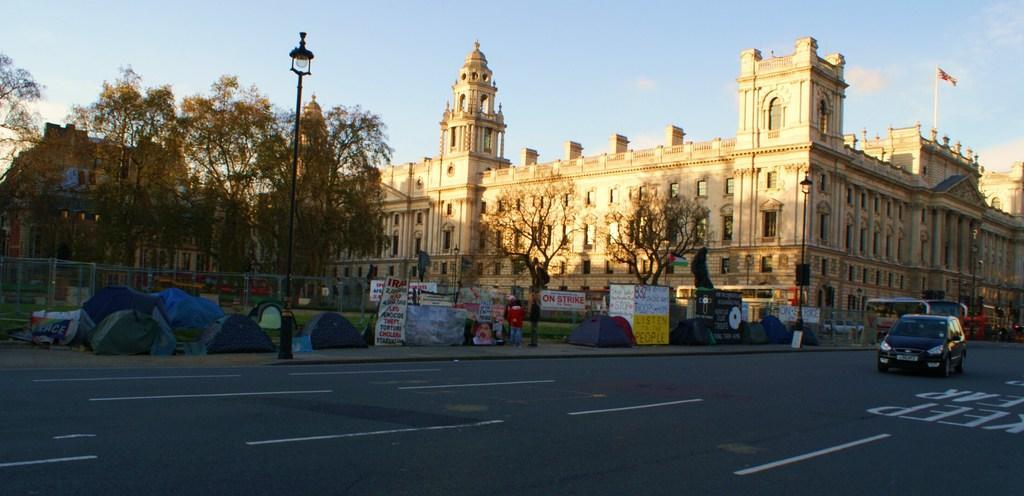Could you give a brief overview of what you see in this image? In this image we can see buildings, trees, there are light poles, tents, there are boards with text on them, there is fencing, there are vehicles on the road, there is a person, also we can see the sky. 